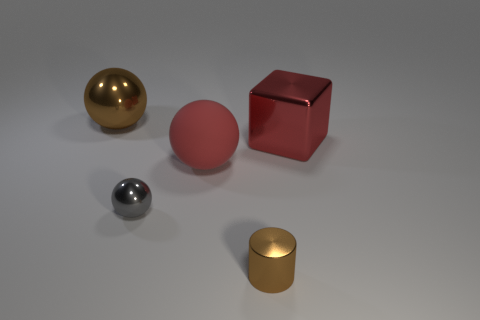Is the shape of the large object that is left of the tiny gray metal object the same as the brown thing to the right of the large brown ball?
Ensure brevity in your answer.  No. There is a cylinder; how many metal blocks are to the left of it?
Give a very brief answer. 0. What color is the tiny thing that is on the left side of the small brown shiny thing?
Make the answer very short. Gray. There is a large metallic object that is the same shape as the matte object; what color is it?
Provide a succinct answer. Brown. Are there any other things that are the same color as the cylinder?
Offer a very short reply. Yes. Are there more red metallic cubes than tiny blue matte balls?
Your answer should be compact. Yes. Is the material of the brown cylinder the same as the gray object?
Provide a short and direct response. Yes. How many small gray things are the same material as the large block?
Keep it short and to the point. 1. Is the size of the rubber ball the same as the brown metal sphere left of the red sphere?
Give a very brief answer. Yes. There is a object that is to the left of the big red rubber thing and behind the small gray metal object; what is its color?
Your answer should be compact. Brown. 